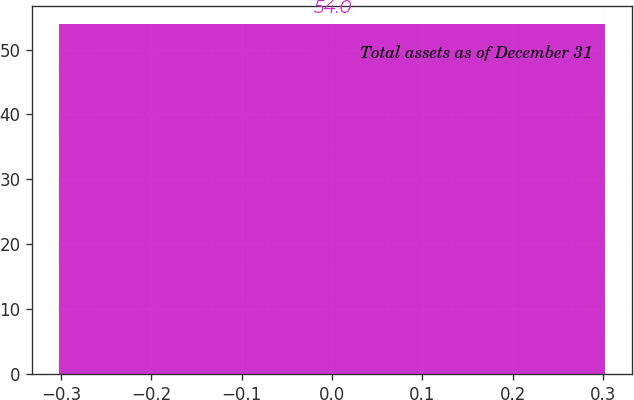Convert chart. <chart><loc_0><loc_0><loc_500><loc_500><bar_chart><fcel>Total assets as of December 31<nl><fcel>54<nl></chart> 